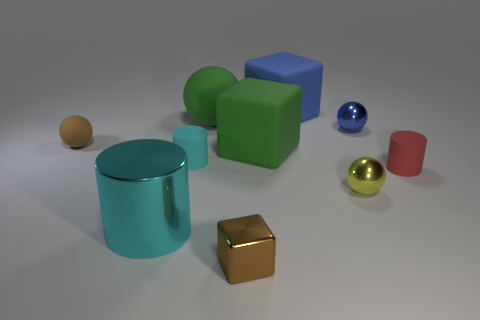There is a small object that is the same color as the tiny rubber sphere; what shape is it?
Provide a succinct answer. Cube. What is the material of the tiny cylinder right of the sphere in front of the red matte thing?
Your answer should be compact. Rubber. Is the shape of the small rubber thing on the right side of the tiny blue object the same as the brown object that is right of the small cyan matte thing?
Provide a short and direct response. No. Are there an equal number of brown things that are to the right of the tiny cyan rubber object and large green rubber blocks?
Your answer should be compact. Yes. Are there any brown cubes behind the metallic sphere that is behind the small cyan cylinder?
Provide a short and direct response. No. Are the tiny brown thing that is left of the small cyan matte cylinder and the blue block made of the same material?
Your response must be concise. Yes. Are there the same number of big green spheres that are behind the big green rubber sphere and large cyan objects that are on the right side of the cyan shiny object?
Keep it short and to the point. Yes. What is the size of the cyan thing in front of the tiny cylinder that is behind the small red cylinder?
Make the answer very short. Large. What is the sphere that is both to the left of the large blue cube and in front of the blue metal sphere made of?
Provide a succinct answer. Rubber. How many other objects are the same size as the blue shiny thing?
Offer a terse response. 5. 